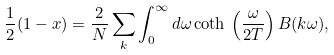Convert formula to latex. <formula><loc_0><loc_0><loc_500><loc_500>\frac { 1 } { 2 } ( 1 - x ) = \frac { 2 } { N } \sum _ { k } \int _ { 0 } ^ { \infty } d \omega \coth \, \left ( \frac { \omega } { 2 T } \right ) B ( { k } \omega ) ,</formula> 